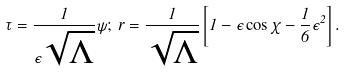<formula> <loc_0><loc_0><loc_500><loc_500>\tau = \frac { 1 } { \epsilon \sqrt { \Lambda } } \psi ; \, r = \frac { 1 } { \sqrt { \Lambda } } \left [ 1 - \epsilon \cos \chi - \frac { 1 } { 6 } \epsilon ^ { 2 } \right ] .</formula> 